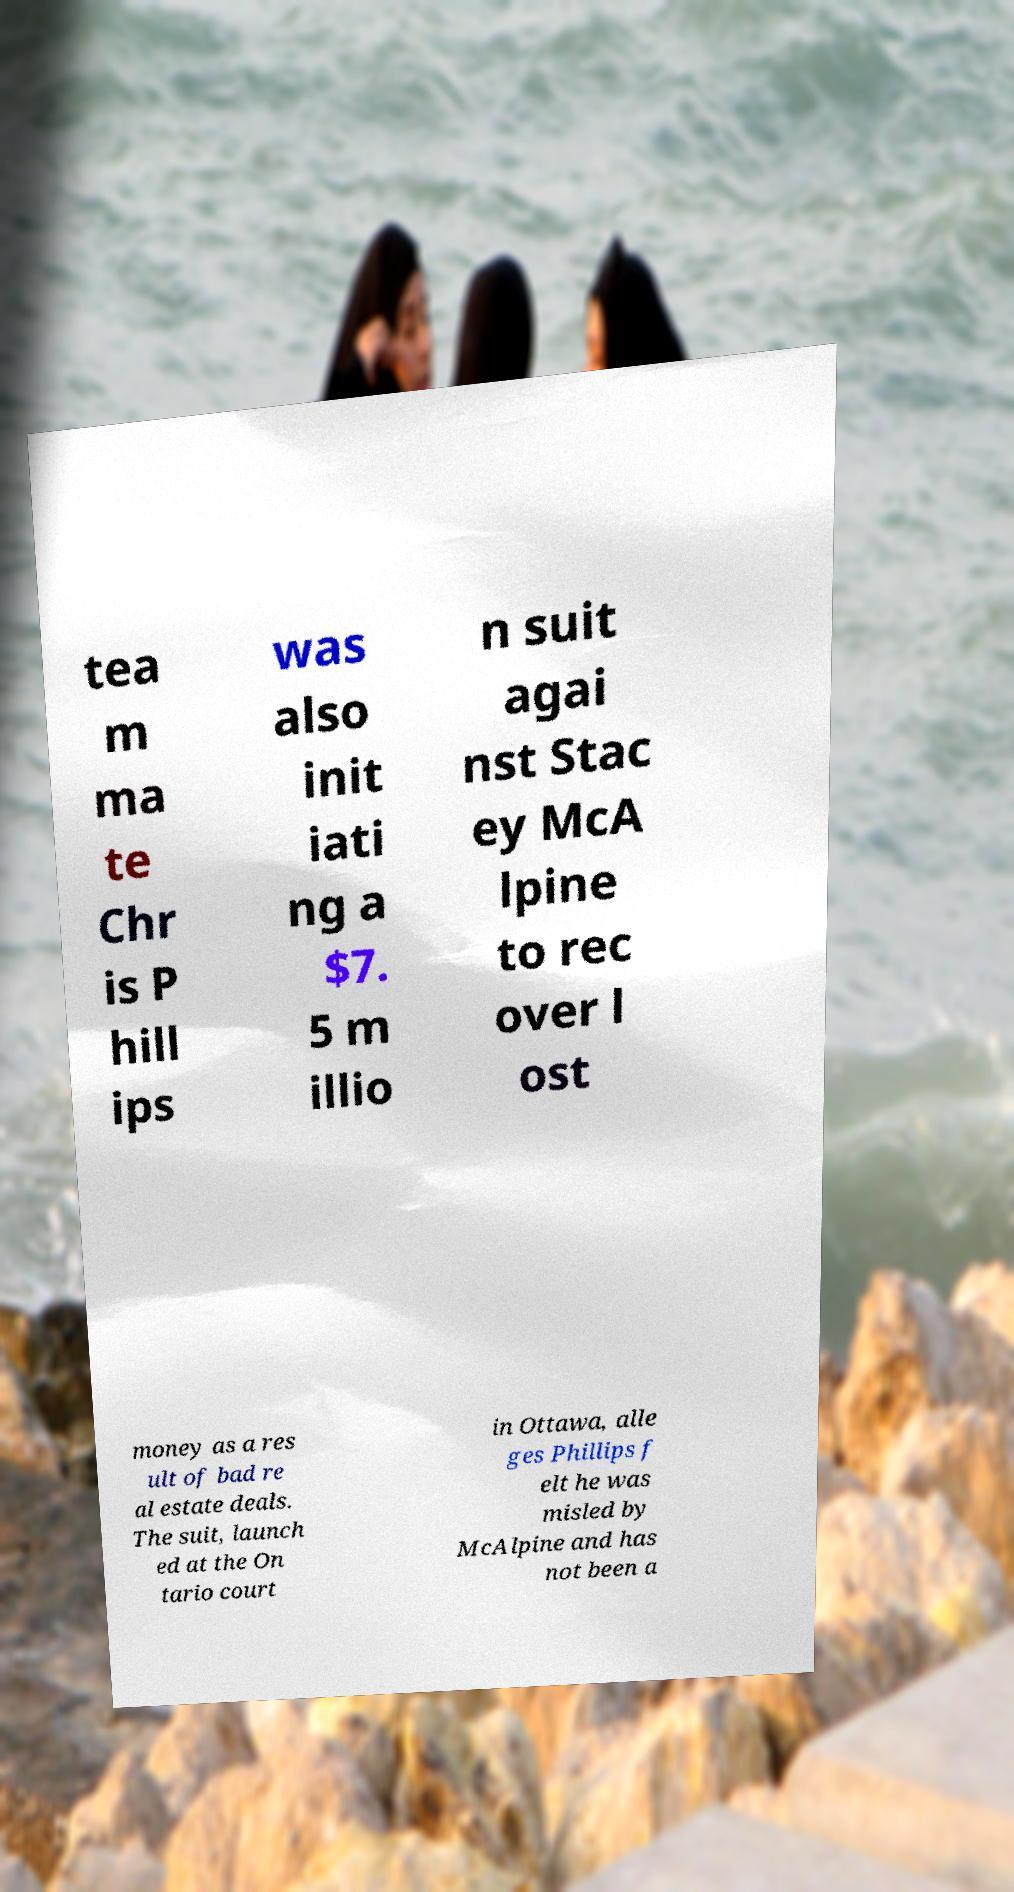There's text embedded in this image that I need extracted. Can you transcribe it verbatim? tea m ma te Chr is P hill ips was also init iati ng a $7. 5 m illio n suit agai nst Stac ey McA lpine to rec over l ost money as a res ult of bad re al estate deals. The suit, launch ed at the On tario court in Ottawa, alle ges Phillips f elt he was misled by McAlpine and has not been a 